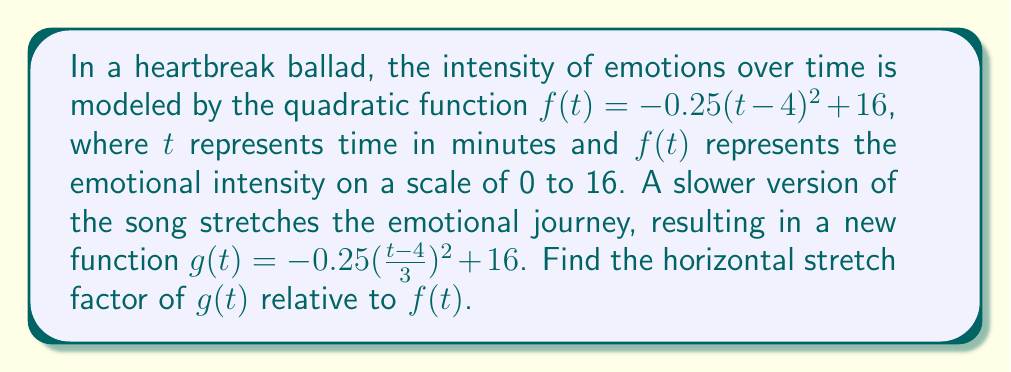Solve this math problem. To find the horizontal stretch factor, we need to compare the general forms of $f(t)$ and $g(t)$:

1) The general form of a quadratic function with a horizontal stretch is:
   $$h(t) = a(\frac{t-h}{k})^2 + v$$
   where $k$ is the horizontal stretch factor.

2) For $f(t) = -0.25(t-4)^2 + 16$, we have:
   $a = -0.25$, $h = 4$, $k = 1$, and $v = 16$

3) For $g(t) = -0.25(\frac{t-4}{3})^2 + 16$, we have:
   $a = -0.25$, $h = 4$, $k = 3$, and $v = 16$

4) The horizontal stretch factor is the value of $k$ in $g(t)$ relative to $f(t)$:
   $\text{Stretch factor} = \frac{k_{g(t)}}{k_{f(t)}} = \frac{3}{1} = 3$

Therefore, $g(t)$ is horizontally stretched by a factor of 3 compared to $f(t)$.
Answer: 3 